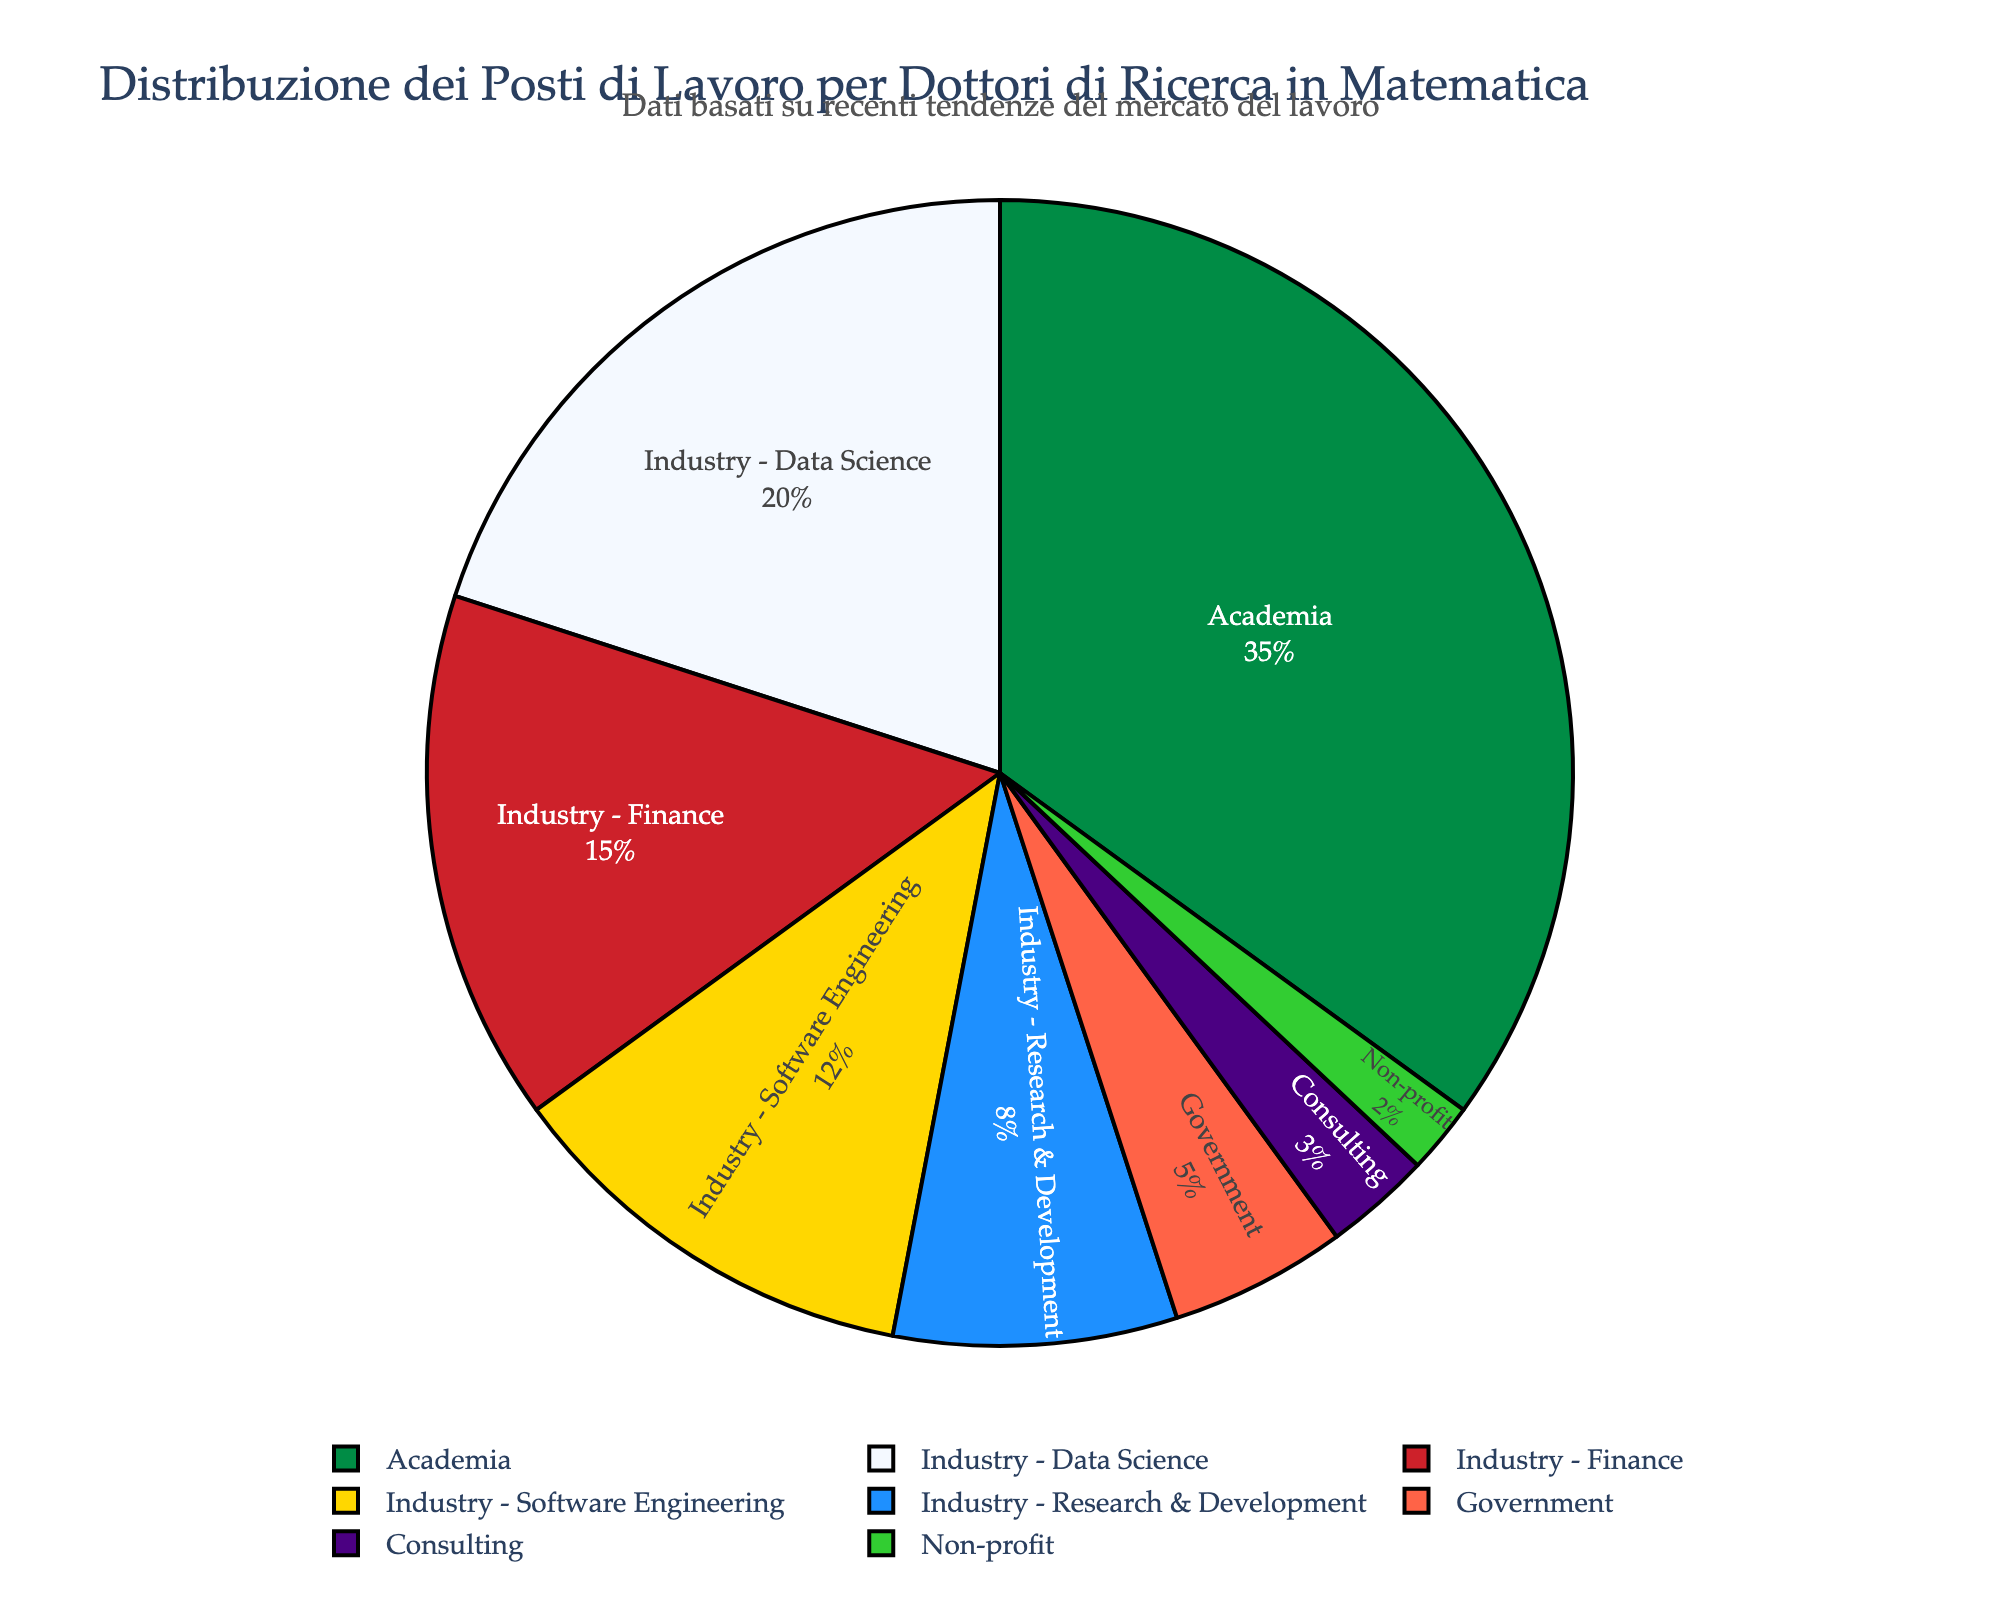Which sector has the largest percentage of job placements? The largest section of the pie chart, which corresponds to the sector with the highest percentage, is 'Academia'.
Answer: Academia Which sectors fall under the 'Industry' category, and what's their combined percentage? The sectors under the 'Industry' category are Data Science, Finance, Software Engineering, and Research & Development. Their combined percentage is 20+15+12+8 = 55%.
Answer: 55% Compare the job placement percentages between 'Government' and 'Non-profit'. Which sector has a higher placement rate and by how much? Government has a job placement percentage of 5%, while Non-profit has 2%. The difference is 5 - 2 = 3 percentage points.
Answer: Government by 3% What percentage of mathematics PhD graduates are placed in sectors other than 'Academia' and 'Government'? Adding up the percentages for all sectors except 'Academia' and 'Government' gives us 20 + 15 + 12 + 8 + 3 + 2 = 60%.
Answer: 60% Is the percentage of graduates in 'Research & Development' higher or lower than those in 'Software Engineering'? By how much? 'Research & Development' has 8%, while 'Software Engineering' has 12%. The difference is 12 - 8 = 4 percentage points.
Answer: Lower by 4% Which sector has the second smallest percentage of job placements, and what is it? The second smallest segment in the pie chart represents Consulting, which has a percentage of 3%.
Answer: Consulting How do the combined job placements in 'Consulting' and 'Non-profit' compare to those in 'Finance'? The combined placements for 'Consulting' and 'Non-profit' are 3 + 2 = 5%, while 'Finance' alone is 15%. Finance has a substantially higher placement rate.
Answer: Finance is higher What is the total percentage of PhD graduates entering non-industry sectors (Academia, Government, Consulting, Non-profit)? Adding up the percentages for Academia, Government, Consulting, and Non-profit, we get 35 + 5 + 3 + 2 = 45%.
Answer: 45% Which sector that falls under 'Industry' has the lowest job placement percentage? Among the industry-related sectors (Data Science, Finance, Software Engineering, Research & Development), Research & Development has the lowest placement percentage of 8%.
Answer: Research & Development 